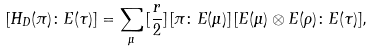<formula> <loc_0><loc_0><loc_500><loc_500>[ H _ { D } ( \pi ) \colon E ( \tau ) ] = \sum _ { \mu } \, [ \frac { r } { 2 } ] \, [ \pi \colon E ( \mu ) ] \, [ E ( \mu ) \otimes E ( \rho ) \colon E ( \tau ) ] ,</formula> 